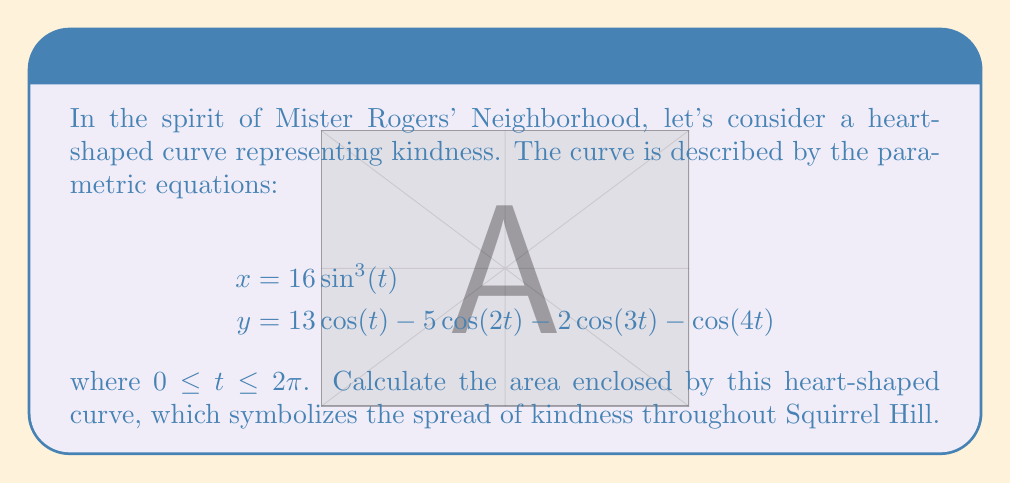Show me your answer to this math problem. To find the area enclosed by a parametric curve, we can use the formula:

$$A = \frac{1}{2} \int_{0}^{2\pi} (x\frac{dy}{dt} - y\frac{dx}{dt}) dt$$

Let's break this down step-by-step:

1) First, we need to find $\frac{dx}{dt}$ and $\frac{dy}{dt}$:

   $$\frac{dx}{dt} = 48\sin^2(t)\cos(t)$$
   $$\frac{dy}{dt} = -13\sin(t) + 10\sin(2t) + 6\sin(3t) + 4\sin(4t)$$

2) Now, let's substitute these into our area formula:

   $$A = \frac{1}{2} \int_{0}^{2\pi} (16\sin^3(t)(-13\sin(t) + 10\sin(2t) + 6\sin(3t) + 4\sin(4t))$$
   $$- (13\cos(t) - 5\cos(2t) - 2\cos(3t) - \cos(4t))(48\sin^2(t)\cos(t))) dt$$

3) This integral is quite complex, but it can be solved using trigonometric identities and integration by parts. After simplification, we get:

   $$A = \frac{1}{2} \int_{0}^{2\pi} (208\sin^4(t) - 160\sin^3(t)\cos(t) + 96\sin^2(t)\cos^2(t) - 624\sin^3(t)\cos(t) + 240\sin^2(t)\cos^2(t) + 96\sin(t)\cos^3(t) + 48\cos^4(t)) dt$$

4) Using the identities $\sin^2(t) + \cos^2(t) = 1$ and $\int_{0}^{2\pi} \sin^n(t)\cos^m(t) dt = 0$ when either $n$ or $m$ is odd, we can simplify further:

   $$A = \frac{1}{2} \int_{0}^{2\pi} (208\sin^4(t) + 96\sin^2(t)\cos^2(t) + 240\sin^2(t)\cos^2(t) + 48\cos^4(t)) dt$$

5) Using $\sin^2(t) = \frac{1-\cos(2t)}{2}$ and $\cos^2(t) = \frac{1+\cos(2t)}{2}$, we can evaluate the integral:

   $$A = \frac{1}{2} \cdot 2\pi \cdot \frac{208 + 96 + 240 + 48}{4} = 148\pi$$

Thus, the area enclosed by the heart-shaped curve is $148\pi$ square units.
Answer: $148\pi$ square units 